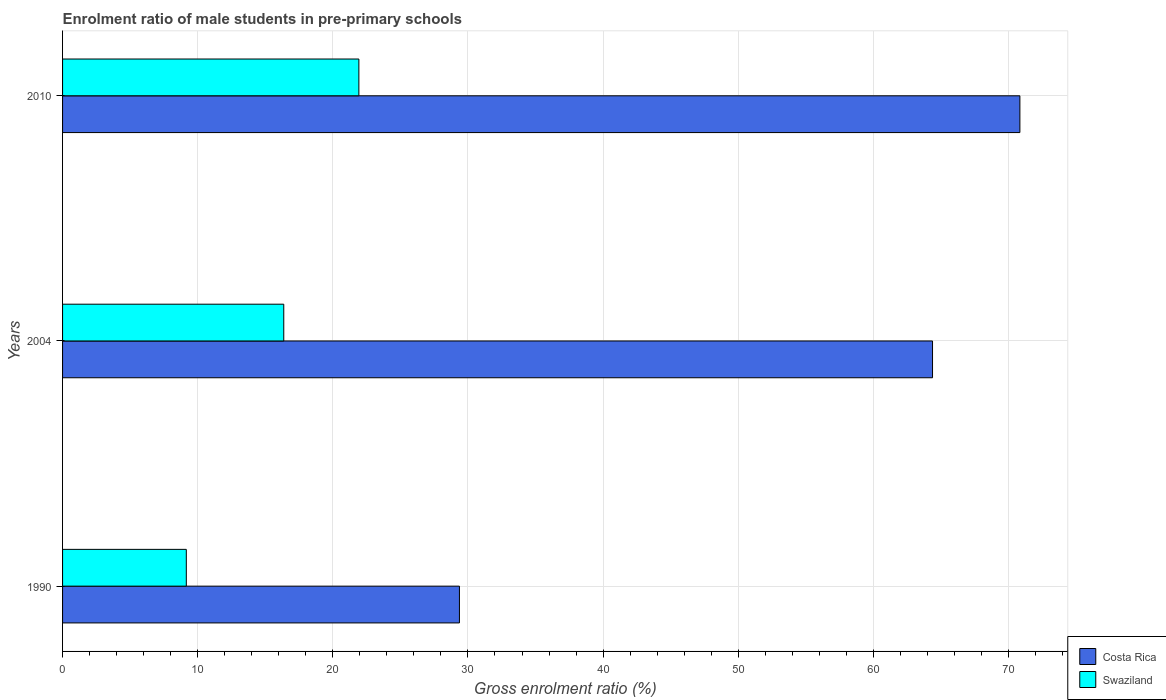How many groups of bars are there?
Provide a succinct answer. 3. Are the number of bars on each tick of the Y-axis equal?
Your answer should be very brief. Yes. How many bars are there on the 1st tick from the bottom?
Make the answer very short. 2. In how many cases, is the number of bars for a given year not equal to the number of legend labels?
Your answer should be very brief. 0. What is the enrolment ratio of male students in pre-primary schools in Swaziland in 2010?
Keep it short and to the point. 21.93. Across all years, what is the maximum enrolment ratio of male students in pre-primary schools in Swaziland?
Offer a terse response. 21.93. Across all years, what is the minimum enrolment ratio of male students in pre-primary schools in Costa Rica?
Make the answer very short. 29.37. What is the total enrolment ratio of male students in pre-primary schools in Costa Rica in the graph?
Your answer should be compact. 164.6. What is the difference between the enrolment ratio of male students in pre-primary schools in Costa Rica in 1990 and that in 2004?
Give a very brief answer. -35.01. What is the difference between the enrolment ratio of male students in pre-primary schools in Swaziland in 2004 and the enrolment ratio of male students in pre-primary schools in Costa Rica in 1990?
Keep it short and to the point. -13. What is the average enrolment ratio of male students in pre-primary schools in Costa Rica per year?
Your answer should be very brief. 54.87. In the year 2010, what is the difference between the enrolment ratio of male students in pre-primary schools in Swaziland and enrolment ratio of male students in pre-primary schools in Costa Rica?
Ensure brevity in your answer.  -48.92. In how many years, is the enrolment ratio of male students in pre-primary schools in Swaziland greater than 66 %?
Ensure brevity in your answer.  0. What is the ratio of the enrolment ratio of male students in pre-primary schools in Swaziland in 1990 to that in 2010?
Give a very brief answer. 0.42. Is the difference between the enrolment ratio of male students in pre-primary schools in Swaziland in 1990 and 2004 greater than the difference between the enrolment ratio of male students in pre-primary schools in Costa Rica in 1990 and 2004?
Ensure brevity in your answer.  Yes. What is the difference between the highest and the second highest enrolment ratio of male students in pre-primary schools in Swaziland?
Your answer should be compact. 5.56. What is the difference between the highest and the lowest enrolment ratio of male students in pre-primary schools in Swaziland?
Ensure brevity in your answer.  12.77. What does the 2nd bar from the top in 1990 represents?
Offer a very short reply. Costa Rica. What does the 2nd bar from the bottom in 2004 represents?
Your response must be concise. Swaziland. Are all the bars in the graph horizontal?
Offer a very short reply. Yes. How many years are there in the graph?
Provide a short and direct response. 3. What is the difference between two consecutive major ticks on the X-axis?
Provide a short and direct response. 10. Are the values on the major ticks of X-axis written in scientific E-notation?
Offer a very short reply. No. Does the graph contain any zero values?
Offer a very short reply. No. Where does the legend appear in the graph?
Your response must be concise. Bottom right. How many legend labels are there?
Offer a terse response. 2. How are the legend labels stacked?
Provide a succinct answer. Vertical. What is the title of the graph?
Your answer should be compact. Enrolment ratio of male students in pre-primary schools. Does "Lower middle income" appear as one of the legend labels in the graph?
Ensure brevity in your answer.  No. What is the label or title of the X-axis?
Give a very brief answer. Gross enrolment ratio (%). What is the label or title of the Y-axis?
Your answer should be compact. Years. What is the Gross enrolment ratio (%) in Costa Rica in 1990?
Make the answer very short. 29.37. What is the Gross enrolment ratio (%) of Swaziland in 1990?
Offer a terse response. 9.16. What is the Gross enrolment ratio (%) in Costa Rica in 2004?
Provide a short and direct response. 64.38. What is the Gross enrolment ratio (%) in Swaziland in 2004?
Offer a terse response. 16.37. What is the Gross enrolment ratio (%) of Costa Rica in 2010?
Your answer should be very brief. 70.85. What is the Gross enrolment ratio (%) of Swaziland in 2010?
Offer a very short reply. 21.93. Across all years, what is the maximum Gross enrolment ratio (%) of Costa Rica?
Make the answer very short. 70.85. Across all years, what is the maximum Gross enrolment ratio (%) of Swaziland?
Ensure brevity in your answer.  21.93. Across all years, what is the minimum Gross enrolment ratio (%) of Costa Rica?
Give a very brief answer. 29.37. Across all years, what is the minimum Gross enrolment ratio (%) in Swaziland?
Provide a succinct answer. 9.16. What is the total Gross enrolment ratio (%) in Costa Rica in the graph?
Keep it short and to the point. 164.6. What is the total Gross enrolment ratio (%) in Swaziland in the graph?
Your answer should be very brief. 47.46. What is the difference between the Gross enrolment ratio (%) of Costa Rica in 1990 and that in 2004?
Your answer should be compact. -35.01. What is the difference between the Gross enrolment ratio (%) in Swaziland in 1990 and that in 2004?
Make the answer very short. -7.21. What is the difference between the Gross enrolment ratio (%) of Costa Rica in 1990 and that in 2010?
Make the answer very short. -41.48. What is the difference between the Gross enrolment ratio (%) of Swaziland in 1990 and that in 2010?
Your answer should be very brief. -12.77. What is the difference between the Gross enrolment ratio (%) of Costa Rica in 2004 and that in 2010?
Give a very brief answer. -6.47. What is the difference between the Gross enrolment ratio (%) of Swaziland in 2004 and that in 2010?
Your response must be concise. -5.56. What is the difference between the Gross enrolment ratio (%) of Costa Rica in 1990 and the Gross enrolment ratio (%) of Swaziland in 2004?
Your answer should be very brief. 13. What is the difference between the Gross enrolment ratio (%) of Costa Rica in 1990 and the Gross enrolment ratio (%) of Swaziland in 2010?
Provide a succinct answer. 7.44. What is the difference between the Gross enrolment ratio (%) of Costa Rica in 2004 and the Gross enrolment ratio (%) of Swaziland in 2010?
Give a very brief answer. 42.45. What is the average Gross enrolment ratio (%) of Costa Rica per year?
Ensure brevity in your answer.  54.87. What is the average Gross enrolment ratio (%) of Swaziland per year?
Provide a succinct answer. 15.82. In the year 1990, what is the difference between the Gross enrolment ratio (%) in Costa Rica and Gross enrolment ratio (%) in Swaziland?
Offer a very short reply. 20.21. In the year 2004, what is the difference between the Gross enrolment ratio (%) of Costa Rica and Gross enrolment ratio (%) of Swaziland?
Make the answer very short. 48.01. In the year 2010, what is the difference between the Gross enrolment ratio (%) in Costa Rica and Gross enrolment ratio (%) in Swaziland?
Provide a short and direct response. 48.92. What is the ratio of the Gross enrolment ratio (%) of Costa Rica in 1990 to that in 2004?
Your answer should be very brief. 0.46. What is the ratio of the Gross enrolment ratio (%) of Swaziland in 1990 to that in 2004?
Offer a terse response. 0.56. What is the ratio of the Gross enrolment ratio (%) of Costa Rica in 1990 to that in 2010?
Offer a terse response. 0.41. What is the ratio of the Gross enrolment ratio (%) of Swaziland in 1990 to that in 2010?
Your answer should be compact. 0.42. What is the ratio of the Gross enrolment ratio (%) of Costa Rica in 2004 to that in 2010?
Your answer should be compact. 0.91. What is the ratio of the Gross enrolment ratio (%) of Swaziland in 2004 to that in 2010?
Provide a succinct answer. 0.75. What is the difference between the highest and the second highest Gross enrolment ratio (%) in Costa Rica?
Your answer should be compact. 6.47. What is the difference between the highest and the second highest Gross enrolment ratio (%) in Swaziland?
Offer a terse response. 5.56. What is the difference between the highest and the lowest Gross enrolment ratio (%) of Costa Rica?
Your answer should be compact. 41.48. What is the difference between the highest and the lowest Gross enrolment ratio (%) of Swaziland?
Offer a very short reply. 12.77. 